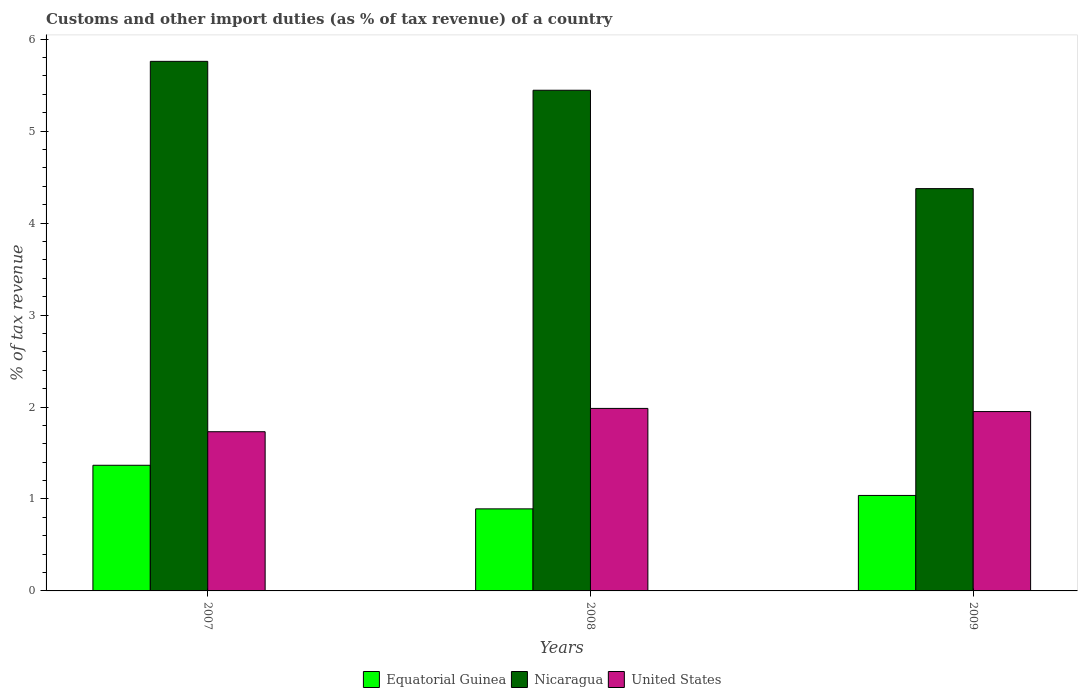How many different coloured bars are there?
Provide a succinct answer. 3. How many bars are there on the 1st tick from the right?
Offer a terse response. 3. In how many cases, is the number of bars for a given year not equal to the number of legend labels?
Provide a short and direct response. 0. What is the percentage of tax revenue from customs in Equatorial Guinea in 2007?
Your response must be concise. 1.37. Across all years, what is the maximum percentage of tax revenue from customs in Nicaragua?
Offer a very short reply. 5.76. Across all years, what is the minimum percentage of tax revenue from customs in Equatorial Guinea?
Your response must be concise. 0.89. In which year was the percentage of tax revenue from customs in United States maximum?
Give a very brief answer. 2008. In which year was the percentage of tax revenue from customs in Equatorial Guinea minimum?
Offer a very short reply. 2008. What is the total percentage of tax revenue from customs in Nicaragua in the graph?
Make the answer very short. 15.58. What is the difference between the percentage of tax revenue from customs in Equatorial Guinea in 2007 and that in 2009?
Offer a very short reply. 0.33. What is the difference between the percentage of tax revenue from customs in Nicaragua in 2007 and the percentage of tax revenue from customs in United States in 2008?
Keep it short and to the point. 3.77. What is the average percentage of tax revenue from customs in United States per year?
Provide a short and direct response. 1.89. In the year 2008, what is the difference between the percentage of tax revenue from customs in United States and percentage of tax revenue from customs in Equatorial Guinea?
Your answer should be compact. 1.09. In how many years, is the percentage of tax revenue from customs in United States greater than 2.8 %?
Your answer should be very brief. 0. What is the ratio of the percentage of tax revenue from customs in United States in 2008 to that in 2009?
Provide a short and direct response. 1.02. Is the difference between the percentage of tax revenue from customs in United States in 2008 and 2009 greater than the difference between the percentage of tax revenue from customs in Equatorial Guinea in 2008 and 2009?
Make the answer very short. Yes. What is the difference between the highest and the second highest percentage of tax revenue from customs in Nicaragua?
Provide a succinct answer. 0.31. What is the difference between the highest and the lowest percentage of tax revenue from customs in United States?
Your answer should be very brief. 0.25. In how many years, is the percentage of tax revenue from customs in Nicaragua greater than the average percentage of tax revenue from customs in Nicaragua taken over all years?
Give a very brief answer. 2. What does the 1st bar from the left in 2009 represents?
Your answer should be very brief. Equatorial Guinea. What does the 2nd bar from the right in 2008 represents?
Provide a succinct answer. Nicaragua. Are the values on the major ticks of Y-axis written in scientific E-notation?
Your response must be concise. No. Does the graph contain any zero values?
Your answer should be compact. No. Where does the legend appear in the graph?
Your answer should be compact. Bottom center. How many legend labels are there?
Offer a very short reply. 3. How are the legend labels stacked?
Your answer should be very brief. Horizontal. What is the title of the graph?
Provide a short and direct response. Customs and other import duties (as % of tax revenue) of a country. What is the label or title of the X-axis?
Your answer should be very brief. Years. What is the label or title of the Y-axis?
Offer a terse response. % of tax revenue. What is the % of tax revenue of Equatorial Guinea in 2007?
Your answer should be very brief. 1.37. What is the % of tax revenue of Nicaragua in 2007?
Your response must be concise. 5.76. What is the % of tax revenue in United States in 2007?
Keep it short and to the point. 1.73. What is the % of tax revenue of Equatorial Guinea in 2008?
Ensure brevity in your answer.  0.89. What is the % of tax revenue of Nicaragua in 2008?
Make the answer very short. 5.44. What is the % of tax revenue of United States in 2008?
Ensure brevity in your answer.  1.98. What is the % of tax revenue in Equatorial Guinea in 2009?
Offer a very short reply. 1.04. What is the % of tax revenue of Nicaragua in 2009?
Offer a very short reply. 4.38. What is the % of tax revenue in United States in 2009?
Provide a succinct answer. 1.95. Across all years, what is the maximum % of tax revenue of Equatorial Guinea?
Your response must be concise. 1.37. Across all years, what is the maximum % of tax revenue of Nicaragua?
Your answer should be very brief. 5.76. Across all years, what is the maximum % of tax revenue of United States?
Keep it short and to the point. 1.98. Across all years, what is the minimum % of tax revenue of Equatorial Guinea?
Offer a very short reply. 0.89. Across all years, what is the minimum % of tax revenue in Nicaragua?
Provide a succinct answer. 4.38. Across all years, what is the minimum % of tax revenue of United States?
Offer a terse response. 1.73. What is the total % of tax revenue in Equatorial Guinea in the graph?
Your answer should be very brief. 3.3. What is the total % of tax revenue in Nicaragua in the graph?
Your response must be concise. 15.58. What is the total % of tax revenue of United States in the graph?
Provide a succinct answer. 5.67. What is the difference between the % of tax revenue of Equatorial Guinea in 2007 and that in 2008?
Offer a very short reply. 0.47. What is the difference between the % of tax revenue in Nicaragua in 2007 and that in 2008?
Keep it short and to the point. 0.31. What is the difference between the % of tax revenue of United States in 2007 and that in 2008?
Offer a very short reply. -0.25. What is the difference between the % of tax revenue in Equatorial Guinea in 2007 and that in 2009?
Provide a succinct answer. 0.33. What is the difference between the % of tax revenue of Nicaragua in 2007 and that in 2009?
Make the answer very short. 1.38. What is the difference between the % of tax revenue in United States in 2007 and that in 2009?
Your answer should be very brief. -0.22. What is the difference between the % of tax revenue of Equatorial Guinea in 2008 and that in 2009?
Make the answer very short. -0.15. What is the difference between the % of tax revenue in Nicaragua in 2008 and that in 2009?
Offer a terse response. 1.07. What is the difference between the % of tax revenue of United States in 2008 and that in 2009?
Offer a terse response. 0.03. What is the difference between the % of tax revenue in Equatorial Guinea in 2007 and the % of tax revenue in Nicaragua in 2008?
Your response must be concise. -4.08. What is the difference between the % of tax revenue in Equatorial Guinea in 2007 and the % of tax revenue in United States in 2008?
Your answer should be compact. -0.62. What is the difference between the % of tax revenue of Nicaragua in 2007 and the % of tax revenue of United States in 2008?
Offer a very short reply. 3.77. What is the difference between the % of tax revenue of Equatorial Guinea in 2007 and the % of tax revenue of Nicaragua in 2009?
Provide a short and direct response. -3.01. What is the difference between the % of tax revenue of Equatorial Guinea in 2007 and the % of tax revenue of United States in 2009?
Ensure brevity in your answer.  -0.58. What is the difference between the % of tax revenue in Nicaragua in 2007 and the % of tax revenue in United States in 2009?
Offer a terse response. 3.81. What is the difference between the % of tax revenue of Equatorial Guinea in 2008 and the % of tax revenue of Nicaragua in 2009?
Provide a succinct answer. -3.48. What is the difference between the % of tax revenue of Equatorial Guinea in 2008 and the % of tax revenue of United States in 2009?
Provide a short and direct response. -1.06. What is the difference between the % of tax revenue in Nicaragua in 2008 and the % of tax revenue in United States in 2009?
Give a very brief answer. 3.49. What is the average % of tax revenue of Equatorial Guinea per year?
Give a very brief answer. 1.1. What is the average % of tax revenue of Nicaragua per year?
Offer a terse response. 5.19. What is the average % of tax revenue in United States per year?
Give a very brief answer. 1.89. In the year 2007, what is the difference between the % of tax revenue of Equatorial Guinea and % of tax revenue of Nicaragua?
Your answer should be very brief. -4.39. In the year 2007, what is the difference between the % of tax revenue of Equatorial Guinea and % of tax revenue of United States?
Keep it short and to the point. -0.36. In the year 2007, what is the difference between the % of tax revenue in Nicaragua and % of tax revenue in United States?
Your response must be concise. 4.03. In the year 2008, what is the difference between the % of tax revenue in Equatorial Guinea and % of tax revenue in Nicaragua?
Provide a short and direct response. -4.55. In the year 2008, what is the difference between the % of tax revenue in Equatorial Guinea and % of tax revenue in United States?
Offer a very short reply. -1.09. In the year 2008, what is the difference between the % of tax revenue of Nicaragua and % of tax revenue of United States?
Your answer should be very brief. 3.46. In the year 2009, what is the difference between the % of tax revenue in Equatorial Guinea and % of tax revenue in Nicaragua?
Keep it short and to the point. -3.34. In the year 2009, what is the difference between the % of tax revenue of Equatorial Guinea and % of tax revenue of United States?
Make the answer very short. -0.91. In the year 2009, what is the difference between the % of tax revenue of Nicaragua and % of tax revenue of United States?
Give a very brief answer. 2.42. What is the ratio of the % of tax revenue of Equatorial Guinea in 2007 to that in 2008?
Keep it short and to the point. 1.53. What is the ratio of the % of tax revenue in Nicaragua in 2007 to that in 2008?
Offer a terse response. 1.06. What is the ratio of the % of tax revenue in United States in 2007 to that in 2008?
Provide a succinct answer. 0.87. What is the ratio of the % of tax revenue of Equatorial Guinea in 2007 to that in 2009?
Keep it short and to the point. 1.32. What is the ratio of the % of tax revenue of Nicaragua in 2007 to that in 2009?
Ensure brevity in your answer.  1.32. What is the ratio of the % of tax revenue of United States in 2007 to that in 2009?
Your response must be concise. 0.89. What is the ratio of the % of tax revenue in Equatorial Guinea in 2008 to that in 2009?
Give a very brief answer. 0.86. What is the ratio of the % of tax revenue of Nicaragua in 2008 to that in 2009?
Make the answer very short. 1.24. What is the ratio of the % of tax revenue in United States in 2008 to that in 2009?
Give a very brief answer. 1.02. What is the difference between the highest and the second highest % of tax revenue of Equatorial Guinea?
Your answer should be very brief. 0.33. What is the difference between the highest and the second highest % of tax revenue of Nicaragua?
Provide a short and direct response. 0.31. What is the difference between the highest and the second highest % of tax revenue of United States?
Your answer should be very brief. 0.03. What is the difference between the highest and the lowest % of tax revenue of Equatorial Guinea?
Your answer should be very brief. 0.47. What is the difference between the highest and the lowest % of tax revenue in Nicaragua?
Give a very brief answer. 1.38. What is the difference between the highest and the lowest % of tax revenue in United States?
Your answer should be compact. 0.25. 